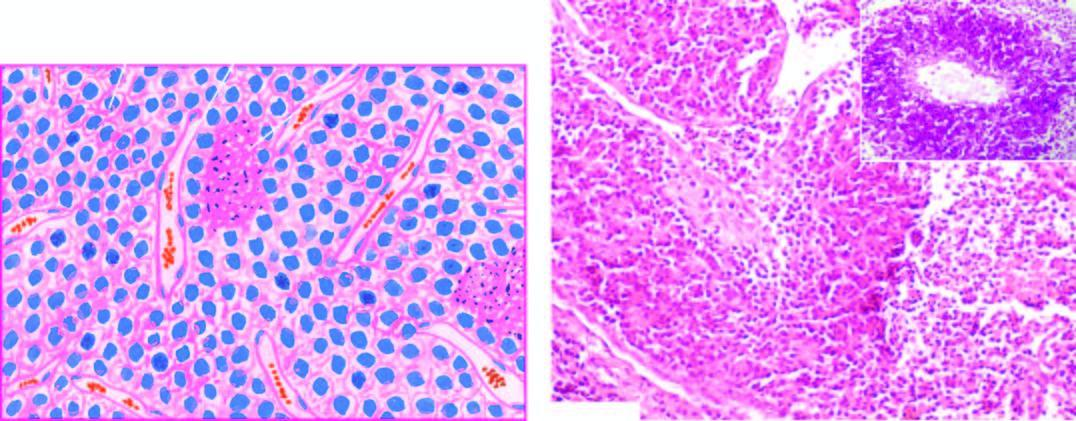what does inbox in the right photomicrograph show?
Answer the question using a single word or phrase. Pas positive tumour cells in perivascular location 